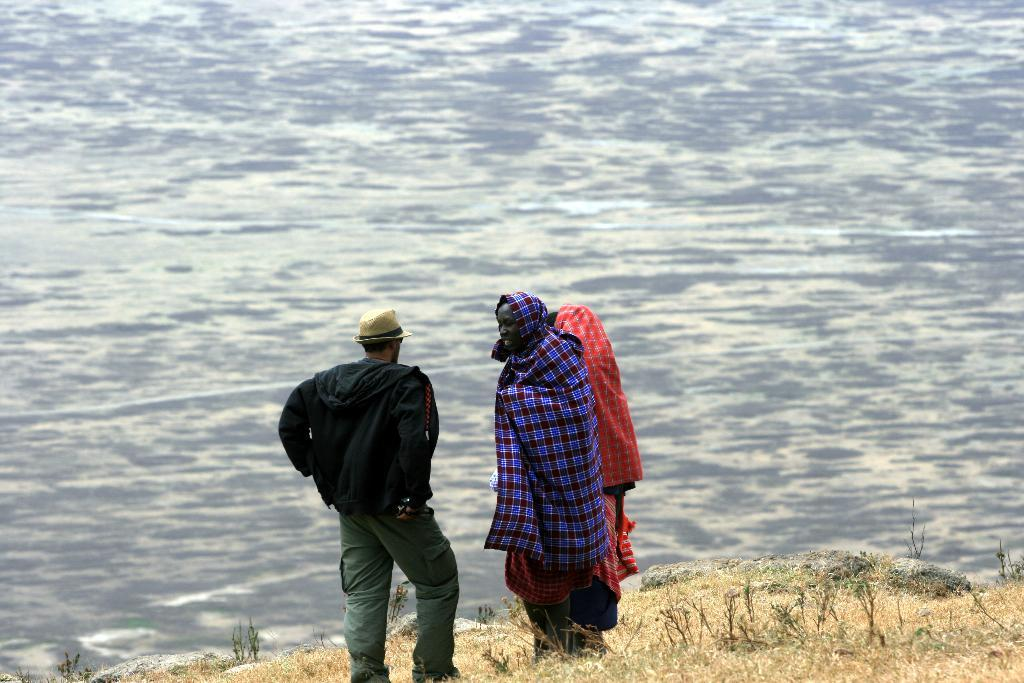How many people are in the image? There are three persons standing in the image. What is the surface they are standing on? The persons are standing on a surface. Can you describe the clothing of one of the persons? One person is wearing a jacket and a hat. What natural element can be seen in the image? There is water visible in the image. What type of cough can be heard coming from the person wearing a jacket and a hat in the image? There is no sound, including coughing, present in the image, so it cannot be determined if any person is coughing. 